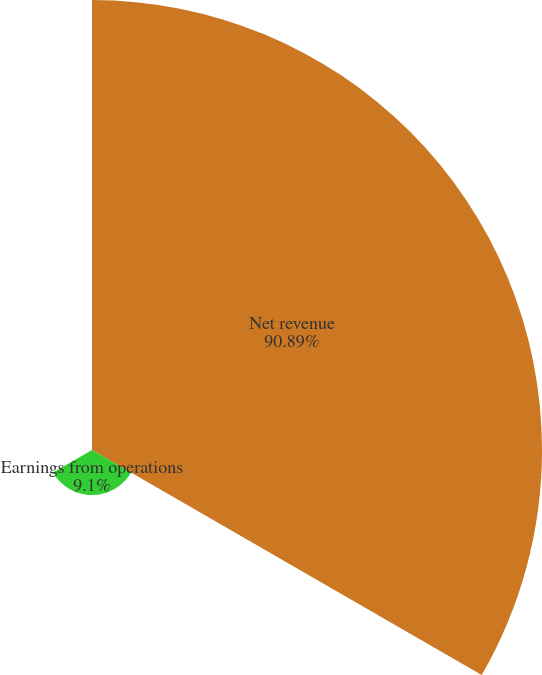Convert chart. <chart><loc_0><loc_0><loc_500><loc_500><pie_chart><fcel>Net revenue<fcel>Earnings from operations<fcel>Earnings from operations as a<nl><fcel>90.89%<fcel>9.1%<fcel>0.01%<nl></chart> 